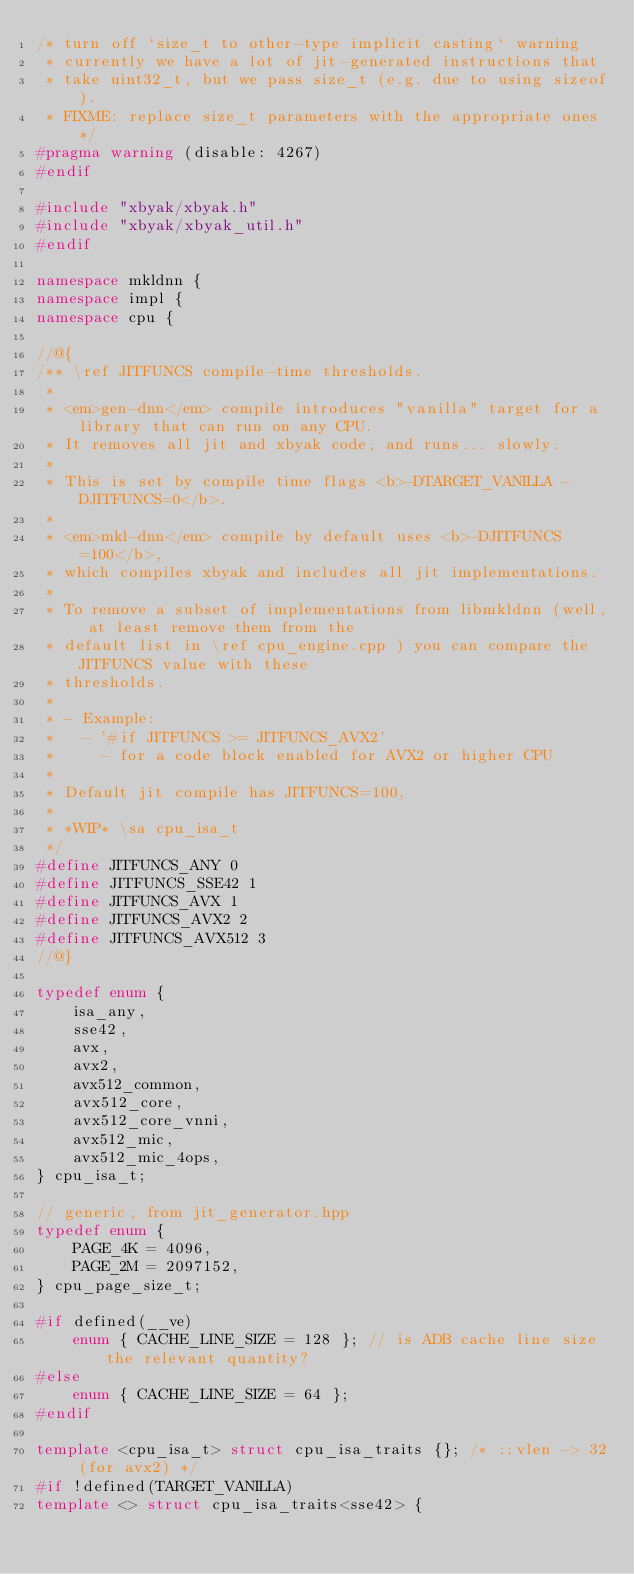Convert code to text. <code><loc_0><loc_0><loc_500><loc_500><_C++_>/* turn off `size_t to other-type implicit casting` warning
 * currently we have a lot of jit-generated instructions that
 * take uint32_t, but we pass size_t (e.g. due to using sizeof).
 * FIXME: replace size_t parameters with the appropriate ones */
#pragma warning (disable: 4267)
#endif

#include "xbyak/xbyak.h"
#include "xbyak/xbyak_util.h"
#endif

namespace mkldnn {
namespace impl {
namespace cpu {

//@{
/** \ref JITFUNCS compile-time thresholds.
 *
 * <em>gen-dnn</em> compile introduces "vanilla" target for a library that can run on any CPU.
 * It removes all jit and xbyak code, and runs... slowly.
 *
 * This is set by compile time flags <b>-DTARGET_VANILLA -DJITFUNCS=0</b>.
 *
 * <em>mkl-dnn</em> compile by default uses <b>-DJITFUNCS=100</b>,
 * which compiles xbyak and includes all jit implementations.
 *
 * To remove a subset of implementations from libmkldnn (well, at least remove them from the
 * default list in \ref cpu_engine.cpp ) you can compare the JITFUNCS value with these
 * thresholds.
 *
 * - Example:
 *   - '#if JITFUNCS >= JITFUNCS_AVX2'
 *     - for a code block enabled for AVX2 or higher CPU
 *
 * Default jit compile has JITFUNCS=100,
 *
 * *WIP* \sa cpu_isa_t
 */
#define JITFUNCS_ANY 0
#define JITFUNCS_SSE42 1
#define JITFUNCS_AVX 1
#define JITFUNCS_AVX2 2
#define JITFUNCS_AVX512 3
//@}

typedef enum {
    isa_any,
    sse42,
    avx,
    avx2,
    avx512_common,
    avx512_core,
    avx512_core_vnni,
    avx512_mic,
    avx512_mic_4ops,
} cpu_isa_t;

// generic, from jit_generator.hpp
typedef enum {
    PAGE_4K = 4096,
    PAGE_2M = 2097152,
} cpu_page_size_t;

#if defined(__ve)
    enum { CACHE_LINE_SIZE = 128 }; // is ADB cache line size the relevant quantity?
#else
    enum { CACHE_LINE_SIZE = 64 };
#endif

template <cpu_isa_t> struct cpu_isa_traits {}; /* ::vlen -> 32 (for avx2) */
#if !defined(TARGET_VANILLA)
template <> struct cpu_isa_traits<sse42> {</code> 